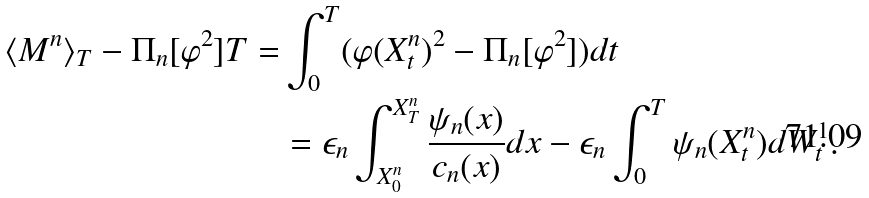Convert formula to latex. <formula><loc_0><loc_0><loc_500><loc_500>\langle M ^ { n } \rangle _ { T } - \Pi _ { n } [ \varphi ^ { 2 } ] T = & \int _ { 0 } ^ { T } ( \varphi ( X ^ { n } _ { t } ) ^ { 2 } - \Pi _ { n } [ \varphi ^ { 2 } ] ) d t \\ & = \epsilon _ { n } \int _ { X ^ { n } _ { 0 } } ^ { X ^ { n } _ { T } } \frac { \psi _ { n } ( x ) } { c _ { n } ( x ) } d x - \epsilon _ { n } \int _ { 0 } ^ { T } \psi _ { n } ( X ^ { n } _ { t } ) d W ^ { 1 } _ { t } .</formula> 